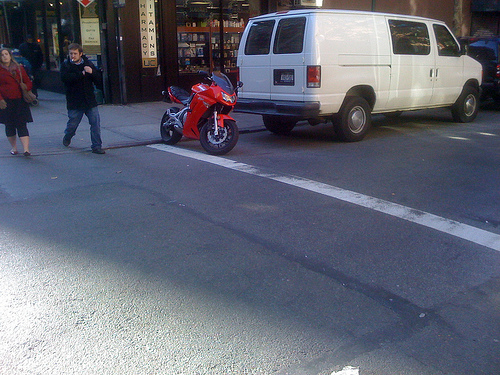<image>
Is there a man on the motorcycle? No. The man is not positioned on the motorcycle. They may be near each other, but the man is not supported by or resting on top of the motorcycle. Is the bike in front of the van? No. The bike is not in front of the van. The spatial positioning shows a different relationship between these objects. Where is the motorcycle in relation to the van? Is it in front of the van? No. The motorcycle is not in front of the van. The spatial positioning shows a different relationship between these objects. 